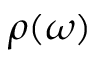<formula> <loc_0><loc_0><loc_500><loc_500>\rho ( \omega )</formula> 